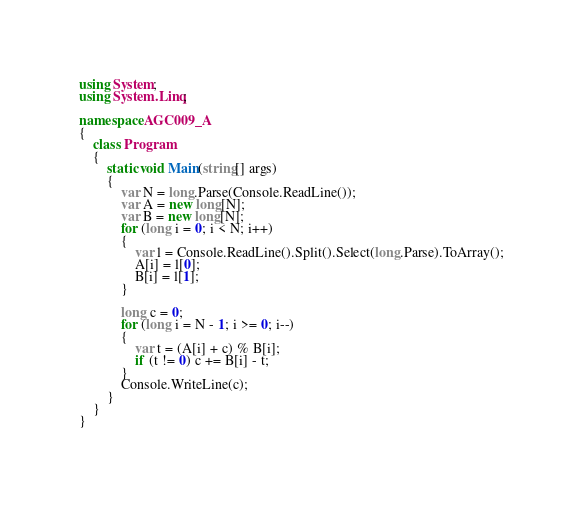Convert code to text. <code><loc_0><loc_0><loc_500><loc_500><_C#_>using System;
using System.Linq;

namespace AGC009_A
{
    class Program
    {
        static void Main(string[] args)
        {
            var N = long.Parse(Console.ReadLine());
            var A = new long[N];
            var B = new long[N];
            for (long i = 0; i < N; i++)
            {
                var l = Console.ReadLine().Split().Select(long.Parse).ToArray();
                A[i] = l[0];
                B[i] = l[1];
            }

            long c = 0;
            for (long i = N - 1; i >= 0; i--)
            {
                var t = (A[i] + c) % B[i];
                if (t != 0) c += B[i] - t;
            }
            Console.WriteLine(c);
        }
    }
}
</code> 